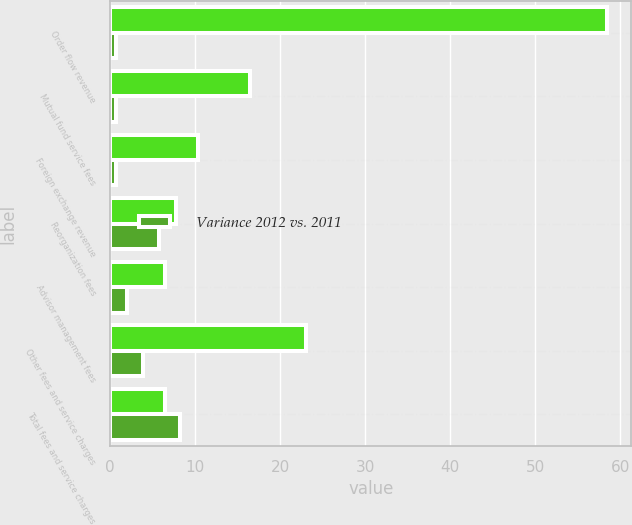Convert chart. <chart><loc_0><loc_0><loc_500><loc_500><stacked_bar_chart><ecel><fcel>Order flow revenue<fcel>Mutual fund service fees<fcel>Foreign exchange revenue<fcel>Reorganization fees<fcel>Advisor management fees<fcel>Other fees and service charges<fcel>Total fees and service charges<nl><fcel>nan<fcel>58.4<fcel>16.4<fcel>10.3<fcel>7.7<fcel>6.4<fcel>23<fcel>6.4<nl><fcel>Variance 2012 vs. 2011<fcel>0.7<fcel>0.7<fcel>0.7<fcel>5.7<fcel>2<fcel>3.8<fcel>8.2<nl></chart> 